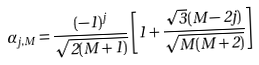Convert formula to latex. <formula><loc_0><loc_0><loc_500><loc_500>\alpha _ { j , M } = \frac { ( - 1 ) ^ { j } } { \sqrt { 2 ( M + 1 ) } } \left [ 1 + \frac { \sqrt { 3 } ( M - 2 j ) } { \sqrt { M ( M + 2 ) } } \right ]</formula> 